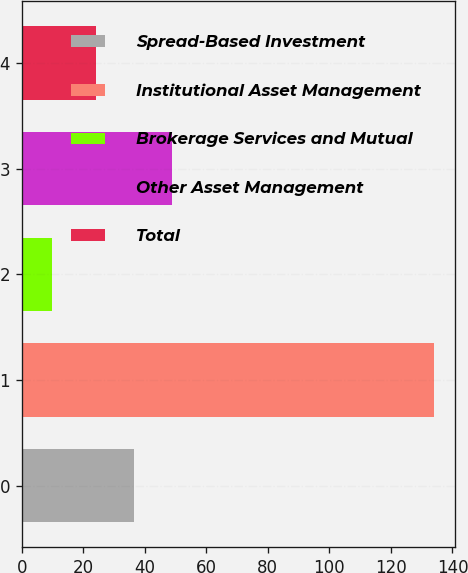Convert chart to OTSL. <chart><loc_0><loc_0><loc_500><loc_500><bar_chart><fcel>Spread-Based Investment<fcel>Institutional Asset Management<fcel>Brokerage Services and Mutual<fcel>Other Asset Management<fcel>Total<nl><fcel>36.4<fcel>134<fcel>10<fcel>48.8<fcel>24<nl></chart> 